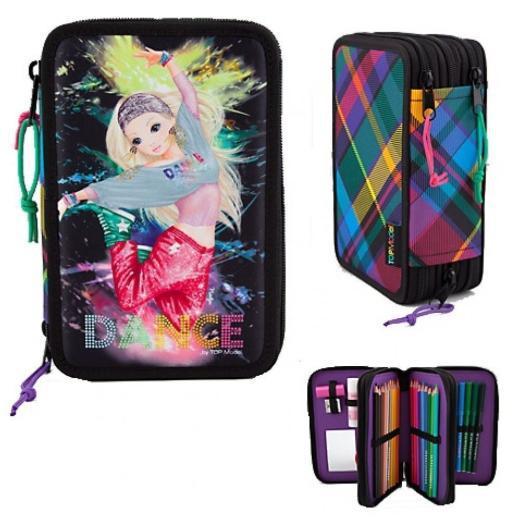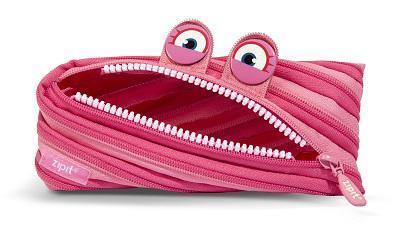The first image is the image on the left, the second image is the image on the right. Analyze the images presented: Is the assertion "The left image shows an overlapping, upright row of at least three color versions of a pencil case style." valid? Answer yes or no. No. The first image is the image on the left, the second image is the image on the right. Evaluate the accuracy of this statement regarding the images: "In at least one image there is a pencil case with colored stripe patterns on the side of the case.". Is it true? Answer yes or no. Yes. 